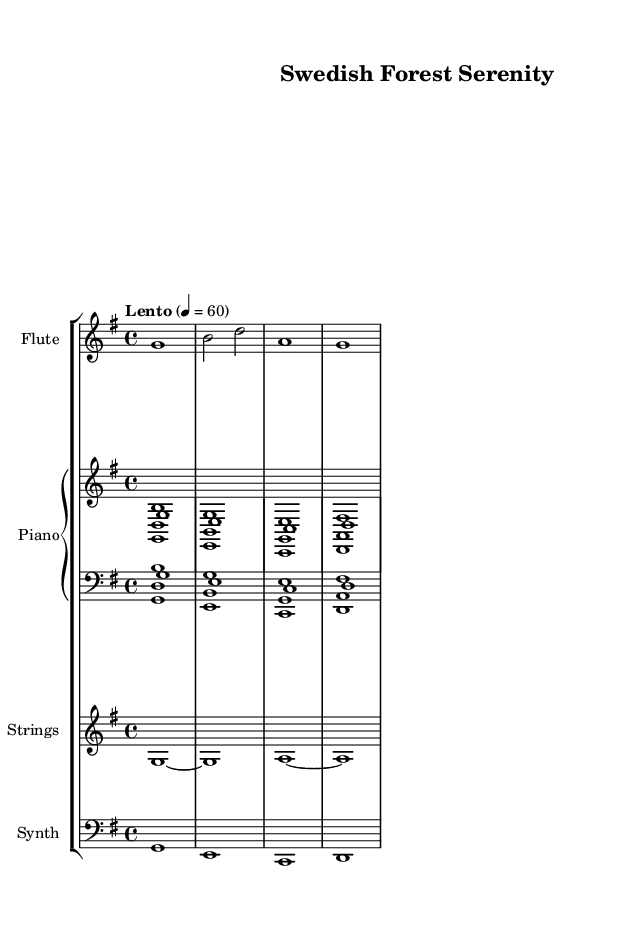What is the key signature of this music? The key signature of the score is G major, which has one sharp (F#). This can be identified by looking at the key signature section noted at the beginning of the staff.
Answer: G major What is the time signature? The time signature is 4/4, indicated at the beginning of the score right after the key signature. This means there are four beats in each measure, and the quarter note gets one beat.
Answer: 4/4 What is the tempo marking? The tempo marking is "Lento," which translates to a slow tempo. This is denoted at the beginning of the sheet music, specifying how the piece should be played.
Answer: Lento How many instruments are present in this score? The score features four different instrumental parts: flute, piano, strings, and synth. This can be observed by examining the different staves in the score layout.
Answer: Four What is the dynamics for the flute part? The dynamics for the flute part are not provided in this section of the sheet music. It is common for ambient music to maintain a soft dynamic level, but there are no specific markings. This indicates that the interpretation of dynamics might be left to the performer.
Answer: None What is the range of the flute part in this piece? The flute part starts on G and goes up to A. This is evident from the notes shown in the flute staff where the notes are notated. The range can be identified by looking at the written notes themselves.
Answer: G to A Which section features harmonic support for the melody? The piano part provides harmonic support for the melody throughout the piece, as it consists of both chords and single notes, creating a fuller sound. This can be determined by analyzing the piano staff where harmonics are played simultaneously with melody notes.
Answer: Piano 